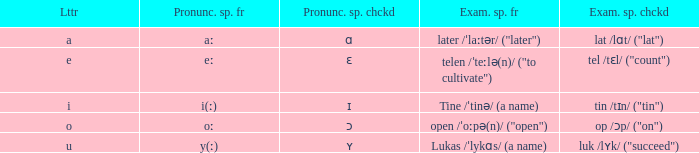What is Example Spelled Free, when Example Spelled Checked is "op /ɔp/ ("on")"? Open /ˈoːpə(n)/ ("open"). 